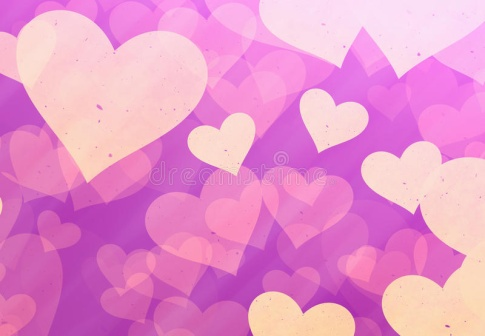What is this photo about? The image is a charming digital illustration featuring a plethora of hearts in various sizes, set against a purple backdrop. The hearts are depicted in soft shades of pink and yellow, giving them a dreamy appearance. They are scattered all over the canvas, with some overlapping and tilted at different angles, which adds to the sense of depth and dynamism. The background transitions from a lighter shade of purple in the top left to a darker shade in the bottom right, creating a lovely gradient effect. The overall ambiance of the image is romantic and whimsical, making it visually engaging despite the lack of any discernible text or specific actions associated with the hearts. The scattered arrangement gives a feeling of randomness, adding to the playful nature of the illustration. 